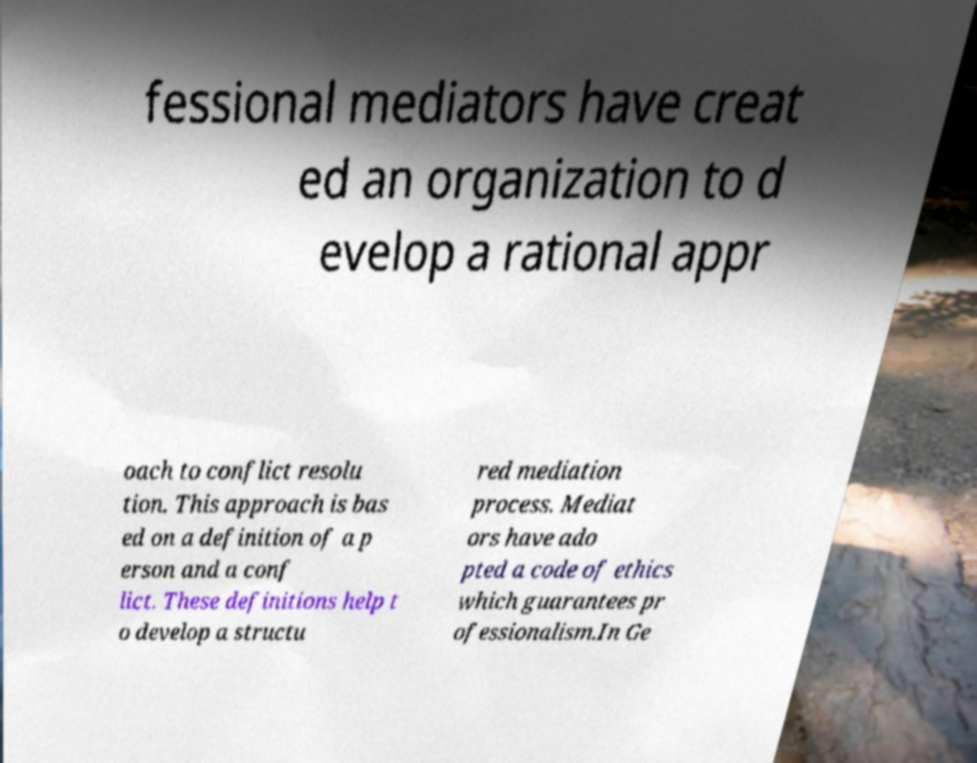Can you accurately transcribe the text from the provided image for me? fessional mediators have creat ed an organization to d evelop a rational appr oach to conflict resolu tion. This approach is bas ed on a definition of a p erson and a conf lict. These definitions help t o develop a structu red mediation process. Mediat ors have ado pted a code of ethics which guarantees pr ofessionalism.In Ge 